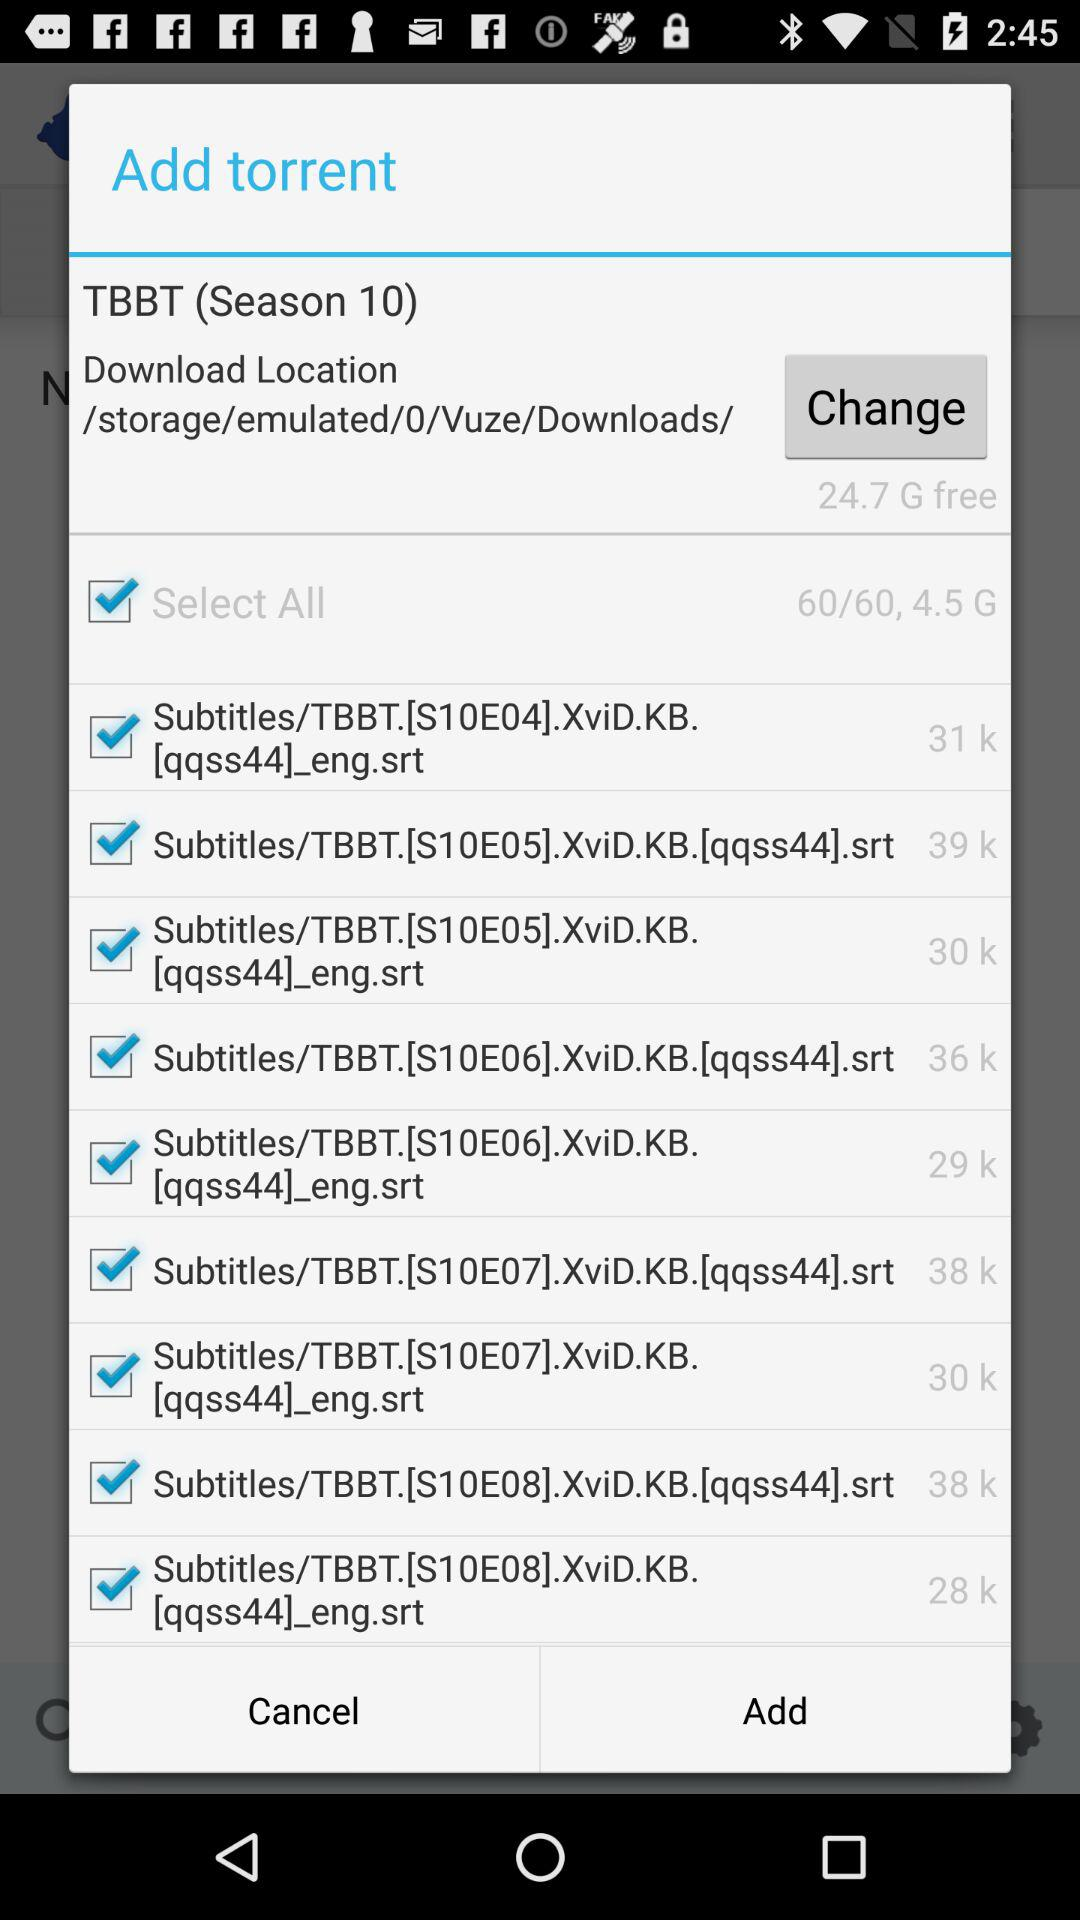How much free space is available on the device?
Answer the question using a single word or phrase. 24.7 G 